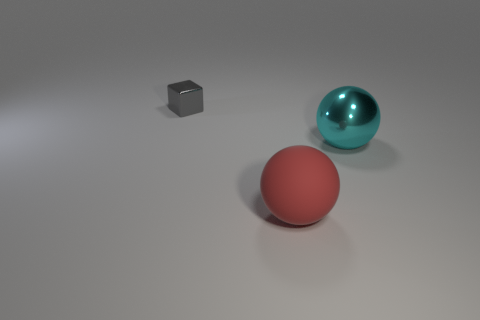Add 2 big red rubber things. How many objects exist? 5 Subtract all spheres. How many objects are left? 1 Subtract all big gray cylinders. Subtract all big rubber things. How many objects are left? 2 Add 3 cyan things. How many cyan things are left? 4 Add 2 large cyan things. How many large cyan things exist? 3 Subtract 0 yellow blocks. How many objects are left? 3 